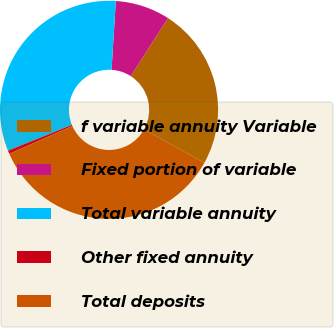Convert chart. <chart><loc_0><loc_0><loc_500><loc_500><pie_chart><fcel>f variable annuity Variable<fcel>Fixed portion of variable<fcel>Total variable annuity<fcel>Other fixed annuity<fcel>Total deposits<nl><fcel>23.99%<fcel>8.1%<fcel>32.09%<fcel>0.51%<fcel>35.3%<nl></chart> 